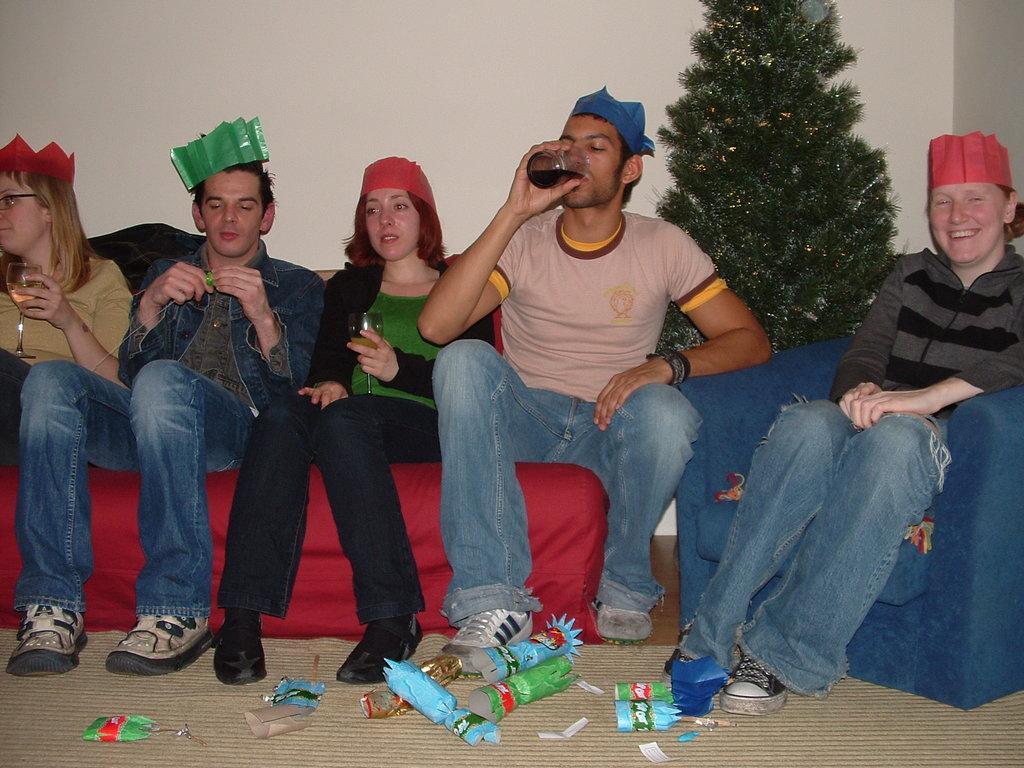Please provide a concise description of this image. In this image we can see people sitting and holding glasses. In the background there is an xmas tree and a wall. At the bottom we can see papers on the mat. 